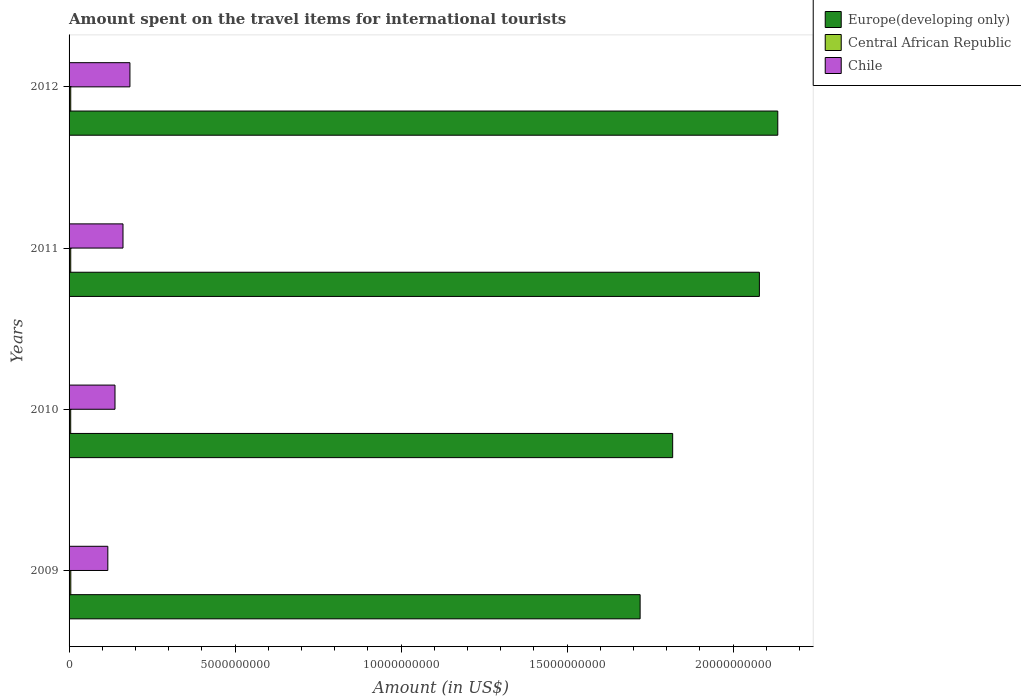Are the number of bars on each tick of the Y-axis equal?
Make the answer very short. Yes. What is the label of the 3rd group of bars from the top?
Provide a short and direct response. 2010. In how many cases, is the number of bars for a given year not equal to the number of legend labels?
Ensure brevity in your answer.  0. What is the amount spent on the travel items for international tourists in Central African Republic in 2010?
Keep it short and to the point. 4.90e+07. Across all years, what is the maximum amount spent on the travel items for international tourists in Europe(developing only)?
Offer a very short reply. 2.13e+1. Across all years, what is the minimum amount spent on the travel items for international tourists in Europe(developing only)?
Your answer should be compact. 1.72e+1. In which year was the amount spent on the travel items for international tourists in Europe(developing only) minimum?
Make the answer very short. 2009. What is the total amount spent on the travel items for international tourists in Europe(developing only) in the graph?
Your response must be concise. 7.75e+1. What is the difference between the amount spent on the travel items for international tourists in Europe(developing only) in 2009 and the amount spent on the travel items for international tourists in Central African Republic in 2012?
Your response must be concise. 1.71e+1. What is the average amount spent on the travel items for international tourists in Europe(developing only) per year?
Offer a very short reply. 1.94e+1. In the year 2012, what is the difference between the amount spent on the travel items for international tourists in Chile and amount spent on the travel items for international tourists in Central African Republic?
Offer a terse response. 1.78e+09. What is the difference between the highest and the second highest amount spent on the travel items for international tourists in Europe(developing only)?
Give a very brief answer. 5.54e+08. What is the difference between the highest and the lowest amount spent on the travel items for international tourists in Europe(developing only)?
Ensure brevity in your answer.  4.15e+09. In how many years, is the amount spent on the travel items for international tourists in Europe(developing only) greater than the average amount spent on the travel items for international tourists in Europe(developing only) taken over all years?
Provide a short and direct response. 2. What does the 3rd bar from the top in 2010 represents?
Your answer should be compact. Europe(developing only). What does the 1st bar from the bottom in 2012 represents?
Your answer should be compact. Europe(developing only). Is it the case that in every year, the sum of the amount spent on the travel items for international tourists in Europe(developing only) and amount spent on the travel items for international tourists in Chile is greater than the amount spent on the travel items for international tourists in Central African Republic?
Your answer should be very brief. Yes. Are all the bars in the graph horizontal?
Offer a very short reply. Yes. What is the difference between two consecutive major ticks on the X-axis?
Give a very brief answer. 5.00e+09. Are the values on the major ticks of X-axis written in scientific E-notation?
Your answer should be very brief. No. Does the graph contain grids?
Your answer should be compact. No. Where does the legend appear in the graph?
Offer a very short reply. Top right. How many legend labels are there?
Keep it short and to the point. 3. How are the legend labels stacked?
Provide a short and direct response. Vertical. What is the title of the graph?
Offer a very short reply. Amount spent on the travel items for international tourists. What is the label or title of the X-axis?
Keep it short and to the point. Amount (in US$). What is the label or title of the Y-axis?
Provide a short and direct response. Years. What is the Amount (in US$) of Europe(developing only) in 2009?
Offer a terse response. 1.72e+1. What is the Amount (in US$) in Central African Republic in 2009?
Offer a very short reply. 5.20e+07. What is the Amount (in US$) of Chile in 2009?
Your response must be concise. 1.17e+09. What is the Amount (in US$) in Europe(developing only) in 2010?
Provide a short and direct response. 1.82e+1. What is the Amount (in US$) of Central African Republic in 2010?
Your answer should be compact. 4.90e+07. What is the Amount (in US$) in Chile in 2010?
Your answer should be very brief. 1.38e+09. What is the Amount (in US$) in Europe(developing only) in 2011?
Provide a short and direct response. 2.08e+1. What is the Amount (in US$) of Chile in 2011?
Your response must be concise. 1.62e+09. What is the Amount (in US$) in Europe(developing only) in 2012?
Ensure brevity in your answer.  2.13e+1. What is the Amount (in US$) in Central African Republic in 2012?
Your answer should be very brief. 5.00e+07. What is the Amount (in US$) in Chile in 2012?
Offer a very short reply. 1.83e+09. Across all years, what is the maximum Amount (in US$) of Europe(developing only)?
Your answer should be very brief. 2.13e+1. Across all years, what is the maximum Amount (in US$) in Central African Republic?
Make the answer very short. 5.20e+07. Across all years, what is the maximum Amount (in US$) in Chile?
Your response must be concise. 1.83e+09. Across all years, what is the minimum Amount (in US$) in Europe(developing only)?
Your answer should be compact. 1.72e+1. Across all years, what is the minimum Amount (in US$) of Central African Republic?
Offer a terse response. 4.90e+07. Across all years, what is the minimum Amount (in US$) of Chile?
Keep it short and to the point. 1.17e+09. What is the total Amount (in US$) in Europe(developing only) in the graph?
Provide a short and direct response. 7.75e+1. What is the total Amount (in US$) of Central African Republic in the graph?
Your response must be concise. 2.01e+08. What is the total Amount (in US$) of Chile in the graph?
Offer a very short reply. 6.01e+09. What is the difference between the Amount (in US$) in Europe(developing only) in 2009 and that in 2010?
Provide a succinct answer. -9.80e+08. What is the difference between the Amount (in US$) of Central African Republic in 2009 and that in 2010?
Give a very brief answer. 3.00e+06. What is the difference between the Amount (in US$) of Chile in 2009 and that in 2010?
Provide a short and direct response. -2.16e+08. What is the difference between the Amount (in US$) in Europe(developing only) in 2009 and that in 2011?
Your answer should be very brief. -3.59e+09. What is the difference between the Amount (in US$) in Chile in 2009 and that in 2011?
Provide a short and direct response. -4.57e+08. What is the difference between the Amount (in US$) of Europe(developing only) in 2009 and that in 2012?
Ensure brevity in your answer.  -4.15e+09. What is the difference between the Amount (in US$) of Central African Republic in 2009 and that in 2012?
Keep it short and to the point. 2.00e+06. What is the difference between the Amount (in US$) in Chile in 2009 and that in 2012?
Keep it short and to the point. -6.66e+08. What is the difference between the Amount (in US$) in Europe(developing only) in 2010 and that in 2011?
Your response must be concise. -2.61e+09. What is the difference between the Amount (in US$) in Chile in 2010 and that in 2011?
Keep it short and to the point. -2.41e+08. What is the difference between the Amount (in US$) in Europe(developing only) in 2010 and that in 2012?
Offer a very short reply. -3.17e+09. What is the difference between the Amount (in US$) in Central African Republic in 2010 and that in 2012?
Offer a terse response. -1.00e+06. What is the difference between the Amount (in US$) of Chile in 2010 and that in 2012?
Provide a succinct answer. -4.50e+08. What is the difference between the Amount (in US$) of Europe(developing only) in 2011 and that in 2012?
Make the answer very short. -5.54e+08. What is the difference between the Amount (in US$) of Central African Republic in 2011 and that in 2012?
Make the answer very short. 0. What is the difference between the Amount (in US$) of Chile in 2011 and that in 2012?
Give a very brief answer. -2.09e+08. What is the difference between the Amount (in US$) of Europe(developing only) in 2009 and the Amount (in US$) of Central African Republic in 2010?
Ensure brevity in your answer.  1.71e+1. What is the difference between the Amount (in US$) of Europe(developing only) in 2009 and the Amount (in US$) of Chile in 2010?
Ensure brevity in your answer.  1.58e+1. What is the difference between the Amount (in US$) of Central African Republic in 2009 and the Amount (in US$) of Chile in 2010?
Offer a terse response. -1.33e+09. What is the difference between the Amount (in US$) in Europe(developing only) in 2009 and the Amount (in US$) in Central African Republic in 2011?
Give a very brief answer. 1.71e+1. What is the difference between the Amount (in US$) of Europe(developing only) in 2009 and the Amount (in US$) of Chile in 2011?
Provide a short and direct response. 1.56e+1. What is the difference between the Amount (in US$) of Central African Republic in 2009 and the Amount (in US$) of Chile in 2011?
Provide a short and direct response. -1.57e+09. What is the difference between the Amount (in US$) of Europe(developing only) in 2009 and the Amount (in US$) of Central African Republic in 2012?
Provide a short and direct response. 1.71e+1. What is the difference between the Amount (in US$) in Europe(developing only) in 2009 and the Amount (in US$) in Chile in 2012?
Provide a succinct answer. 1.54e+1. What is the difference between the Amount (in US$) in Central African Republic in 2009 and the Amount (in US$) in Chile in 2012?
Your answer should be compact. -1.78e+09. What is the difference between the Amount (in US$) in Europe(developing only) in 2010 and the Amount (in US$) in Central African Republic in 2011?
Keep it short and to the point. 1.81e+1. What is the difference between the Amount (in US$) of Europe(developing only) in 2010 and the Amount (in US$) of Chile in 2011?
Your answer should be very brief. 1.66e+1. What is the difference between the Amount (in US$) in Central African Republic in 2010 and the Amount (in US$) in Chile in 2011?
Provide a succinct answer. -1.58e+09. What is the difference between the Amount (in US$) in Europe(developing only) in 2010 and the Amount (in US$) in Central African Republic in 2012?
Keep it short and to the point. 1.81e+1. What is the difference between the Amount (in US$) of Europe(developing only) in 2010 and the Amount (in US$) of Chile in 2012?
Your answer should be very brief. 1.63e+1. What is the difference between the Amount (in US$) of Central African Republic in 2010 and the Amount (in US$) of Chile in 2012?
Make the answer very short. -1.78e+09. What is the difference between the Amount (in US$) of Europe(developing only) in 2011 and the Amount (in US$) of Central African Republic in 2012?
Your answer should be very brief. 2.07e+1. What is the difference between the Amount (in US$) of Europe(developing only) in 2011 and the Amount (in US$) of Chile in 2012?
Give a very brief answer. 1.90e+1. What is the difference between the Amount (in US$) in Central African Republic in 2011 and the Amount (in US$) in Chile in 2012?
Provide a short and direct response. -1.78e+09. What is the average Amount (in US$) of Europe(developing only) per year?
Give a very brief answer. 1.94e+1. What is the average Amount (in US$) of Central African Republic per year?
Make the answer very short. 5.02e+07. What is the average Amount (in US$) in Chile per year?
Provide a succinct answer. 1.50e+09. In the year 2009, what is the difference between the Amount (in US$) in Europe(developing only) and Amount (in US$) in Central African Republic?
Offer a terse response. 1.71e+1. In the year 2009, what is the difference between the Amount (in US$) in Europe(developing only) and Amount (in US$) in Chile?
Offer a very short reply. 1.60e+1. In the year 2009, what is the difference between the Amount (in US$) in Central African Republic and Amount (in US$) in Chile?
Provide a short and direct response. -1.12e+09. In the year 2010, what is the difference between the Amount (in US$) in Europe(developing only) and Amount (in US$) in Central African Republic?
Your response must be concise. 1.81e+1. In the year 2010, what is the difference between the Amount (in US$) of Europe(developing only) and Amount (in US$) of Chile?
Offer a terse response. 1.68e+1. In the year 2010, what is the difference between the Amount (in US$) in Central African Republic and Amount (in US$) in Chile?
Your response must be concise. -1.33e+09. In the year 2011, what is the difference between the Amount (in US$) of Europe(developing only) and Amount (in US$) of Central African Republic?
Your answer should be very brief. 2.07e+1. In the year 2011, what is the difference between the Amount (in US$) in Europe(developing only) and Amount (in US$) in Chile?
Your answer should be very brief. 1.92e+1. In the year 2011, what is the difference between the Amount (in US$) in Central African Republic and Amount (in US$) in Chile?
Your answer should be compact. -1.57e+09. In the year 2012, what is the difference between the Amount (in US$) in Europe(developing only) and Amount (in US$) in Central African Republic?
Give a very brief answer. 2.13e+1. In the year 2012, what is the difference between the Amount (in US$) in Europe(developing only) and Amount (in US$) in Chile?
Your answer should be compact. 1.95e+1. In the year 2012, what is the difference between the Amount (in US$) of Central African Republic and Amount (in US$) of Chile?
Offer a terse response. -1.78e+09. What is the ratio of the Amount (in US$) of Europe(developing only) in 2009 to that in 2010?
Provide a succinct answer. 0.95. What is the ratio of the Amount (in US$) in Central African Republic in 2009 to that in 2010?
Give a very brief answer. 1.06. What is the ratio of the Amount (in US$) of Chile in 2009 to that in 2010?
Your response must be concise. 0.84. What is the ratio of the Amount (in US$) in Europe(developing only) in 2009 to that in 2011?
Make the answer very short. 0.83. What is the ratio of the Amount (in US$) of Central African Republic in 2009 to that in 2011?
Ensure brevity in your answer.  1.04. What is the ratio of the Amount (in US$) of Chile in 2009 to that in 2011?
Your answer should be compact. 0.72. What is the ratio of the Amount (in US$) of Europe(developing only) in 2009 to that in 2012?
Offer a terse response. 0.81. What is the ratio of the Amount (in US$) in Central African Republic in 2009 to that in 2012?
Ensure brevity in your answer.  1.04. What is the ratio of the Amount (in US$) in Chile in 2009 to that in 2012?
Your answer should be very brief. 0.64. What is the ratio of the Amount (in US$) in Europe(developing only) in 2010 to that in 2011?
Your response must be concise. 0.87. What is the ratio of the Amount (in US$) in Central African Republic in 2010 to that in 2011?
Make the answer very short. 0.98. What is the ratio of the Amount (in US$) of Chile in 2010 to that in 2011?
Ensure brevity in your answer.  0.85. What is the ratio of the Amount (in US$) of Europe(developing only) in 2010 to that in 2012?
Keep it short and to the point. 0.85. What is the ratio of the Amount (in US$) in Chile in 2010 to that in 2012?
Your answer should be very brief. 0.75. What is the ratio of the Amount (in US$) of Europe(developing only) in 2011 to that in 2012?
Your answer should be very brief. 0.97. What is the ratio of the Amount (in US$) in Central African Republic in 2011 to that in 2012?
Ensure brevity in your answer.  1. What is the ratio of the Amount (in US$) in Chile in 2011 to that in 2012?
Your answer should be compact. 0.89. What is the difference between the highest and the second highest Amount (in US$) of Europe(developing only)?
Provide a short and direct response. 5.54e+08. What is the difference between the highest and the second highest Amount (in US$) of Chile?
Offer a terse response. 2.09e+08. What is the difference between the highest and the lowest Amount (in US$) in Europe(developing only)?
Your answer should be very brief. 4.15e+09. What is the difference between the highest and the lowest Amount (in US$) in Central African Republic?
Your answer should be very brief. 3.00e+06. What is the difference between the highest and the lowest Amount (in US$) of Chile?
Your response must be concise. 6.66e+08. 